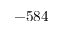Convert formula to latex. <formula><loc_0><loc_0><loc_500><loc_500>- 5 8 4</formula> 